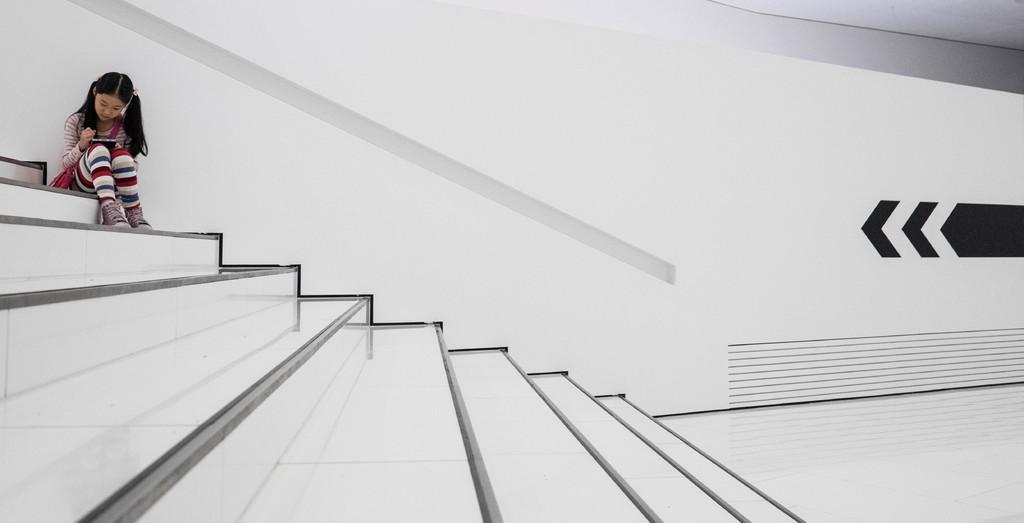Please provide a concise description of this image. This picture is clicked inside. On the left there is a girl holding an object and sitting on the stair. In the background there is a wall and on the wall we can see the black color sign of speed. 